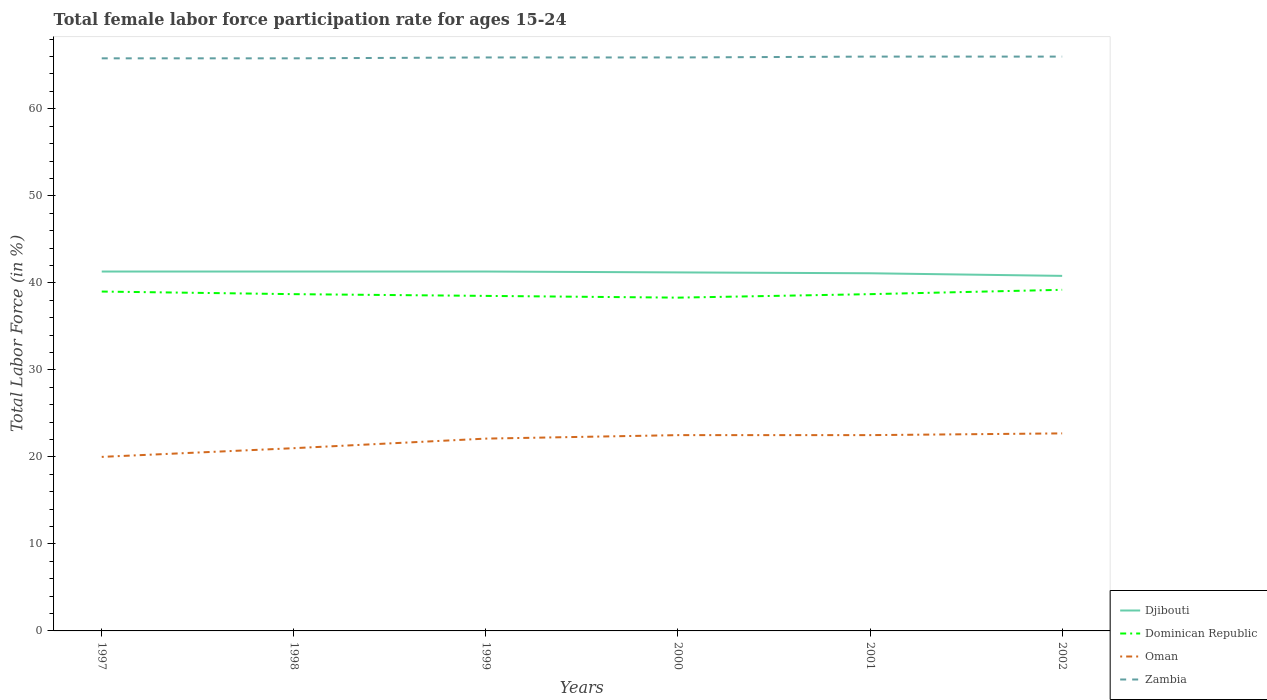How many different coloured lines are there?
Your answer should be very brief. 4. Across all years, what is the maximum female labor force participation rate in Zambia?
Your answer should be compact. 65.8. What is the total female labor force participation rate in Djibouti in the graph?
Offer a very short reply. 0.1. What is the difference between the highest and the second highest female labor force participation rate in Zambia?
Make the answer very short. 0.2. Is the female labor force participation rate in Djibouti strictly greater than the female labor force participation rate in Oman over the years?
Your response must be concise. No. How many lines are there?
Your answer should be compact. 4. Does the graph contain any zero values?
Provide a succinct answer. No. What is the title of the graph?
Offer a very short reply. Total female labor force participation rate for ages 15-24. Does "Macao" appear as one of the legend labels in the graph?
Offer a terse response. No. What is the Total Labor Force (in %) of Djibouti in 1997?
Your answer should be compact. 41.3. What is the Total Labor Force (in %) in Zambia in 1997?
Keep it short and to the point. 65.8. What is the Total Labor Force (in %) in Djibouti in 1998?
Your answer should be compact. 41.3. What is the Total Labor Force (in %) in Dominican Republic in 1998?
Your answer should be very brief. 38.7. What is the Total Labor Force (in %) of Oman in 1998?
Provide a short and direct response. 21. What is the Total Labor Force (in %) of Zambia in 1998?
Ensure brevity in your answer.  65.8. What is the Total Labor Force (in %) in Djibouti in 1999?
Make the answer very short. 41.3. What is the Total Labor Force (in %) of Dominican Republic in 1999?
Your answer should be compact. 38.5. What is the Total Labor Force (in %) in Oman in 1999?
Make the answer very short. 22.1. What is the Total Labor Force (in %) in Zambia in 1999?
Ensure brevity in your answer.  65.9. What is the Total Labor Force (in %) of Djibouti in 2000?
Offer a very short reply. 41.2. What is the Total Labor Force (in %) in Dominican Republic in 2000?
Offer a terse response. 38.3. What is the Total Labor Force (in %) in Oman in 2000?
Your answer should be very brief. 22.5. What is the Total Labor Force (in %) of Zambia in 2000?
Your response must be concise. 65.9. What is the Total Labor Force (in %) of Djibouti in 2001?
Your answer should be very brief. 41.1. What is the Total Labor Force (in %) of Dominican Republic in 2001?
Offer a very short reply. 38.7. What is the Total Labor Force (in %) of Zambia in 2001?
Provide a short and direct response. 66. What is the Total Labor Force (in %) of Djibouti in 2002?
Ensure brevity in your answer.  40.8. What is the Total Labor Force (in %) of Dominican Republic in 2002?
Keep it short and to the point. 39.2. What is the Total Labor Force (in %) in Oman in 2002?
Provide a short and direct response. 22.7. What is the Total Labor Force (in %) in Zambia in 2002?
Keep it short and to the point. 66. Across all years, what is the maximum Total Labor Force (in %) in Djibouti?
Keep it short and to the point. 41.3. Across all years, what is the maximum Total Labor Force (in %) in Dominican Republic?
Keep it short and to the point. 39.2. Across all years, what is the maximum Total Labor Force (in %) in Oman?
Your answer should be compact. 22.7. Across all years, what is the minimum Total Labor Force (in %) of Djibouti?
Provide a short and direct response. 40.8. Across all years, what is the minimum Total Labor Force (in %) in Dominican Republic?
Provide a succinct answer. 38.3. Across all years, what is the minimum Total Labor Force (in %) of Zambia?
Provide a succinct answer. 65.8. What is the total Total Labor Force (in %) in Djibouti in the graph?
Provide a succinct answer. 247. What is the total Total Labor Force (in %) of Dominican Republic in the graph?
Provide a succinct answer. 232.4. What is the total Total Labor Force (in %) in Oman in the graph?
Provide a short and direct response. 130.8. What is the total Total Labor Force (in %) of Zambia in the graph?
Offer a terse response. 395.4. What is the difference between the Total Labor Force (in %) in Dominican Republic in 1997 and that in 1998?
Your answer should be very brief. 0.3. What is the difference between the Total Labor Force (in %) in Zambia in 1997 and that in 1998?
Offer a terse response. 0. What is the difference between the Total Labor Force (in %) of Dominican Republic in 1997 and that in 1999?
Your response must be concise. 0.5. What is the difference between the Total Labor Force (in %) of Oman in 1997 and that in 1999?
Your response must be concise. -2.1. What is the difference between the Total Labor Force (in %) in Djibouti in 1997 and that in 2000?
Ensure brevity in your answer.  0.1. What is the difference between the Total Labor Force (in %) of Oman in 1997 and that in 2000?
Provide a short and direct response. -2.5. What is the difference between the Total Labor Force (in %) in Zambia in 1997 and that in 2000?
Make the answer very short. -0.1. What is the difference between the Total Labor Force (in %) of Djibouti in 1997 and that in 2001?
Offer a terse response. 0.2. What is the difference between the Total Labor Force (in %) of Dominican Republic in 1997 and that in 2001?
Your answer should be very brief. 0.3. What is the difference between the Total Labor Force (in %) in Oman in 1997 and that in 2001?
Your answer should be very brief. -2.5. What is the difference between the Total Labor Force (in %) of Zambia in 1997 and that in 2001?
Your answer should be compact. -0.2. What is the difference between the Total Labor Force (in %) in Dominican Republic in 1997 and that in 2002?
Keep it short and to the point. -0.2. What is the difference between the Total Labor Force (in %) in Zambia in 1997 and that in 2002?
Give a very brief answer. -0.2. What is the difference between the Total Labor Force (in %) in Djibouti in 1998 and that in 1999?
Offer a terse response. 0. What is the difference between the Total Labor Force (in %) in Dominican Republic in 1998 and that in 1999?
Offer a very short reply. 0.2. What is the difference between the Total Labor Force (in %) of Djibouti in 1998 and that in 2000?
Your answer should be very brief. 0.1. What is the difference between the Total Labor Force (in %) of Dominican Republic in 1998 and that in 2000?
Your answer should be compact. 0.4. What is the difference between the Total Labor Force (in %) of Oman in 1998 and that in 2000?
Offer a very short reply. -1.5. What is the difference between the Total Labor Force (in %) in Djibouti in 1998 and that in 2001?
Your answer should be compact. 0.2. What is the difference between the Total Labor Force (in %) of Dominican Republic in 1998 and that in 2001?
Keep it short and to the point. 0. What is the difference between the Total Labor Force (in %) in Oman in 1998 and that in 2001?
Provide a succinct answer. -1.5. What is the difference between the Total Labor Force (in %) in Oman in 1998 and that in 2002?
Ensure brevity in your answer.  -1.7. What is the difference between the Total Labor Force (in %) of Zambia in 1998 and that in 2002?
Give a very brief answer. -0.2. What is the difference between the Total Labor Force (in %) of Djibouti in 1999 and that in 2000?
Make the answer very short. 0.1. What is the difference between the Total Labor Force (in %) in Dominican Republic in 1999 and that in 2000?
Your answer should be very brief. 0.2. What is the difference between the Total Labor Force (in %) of Oman in 1999 and that in 2000?
Offer a very short reply. -0.4. What is the difference between the Total Labor Force (in %) of Dominican Republic in 1999 and that in 2001?
Offer a very short reply. -0.2. What is the difference between the Total Labor Force (in %) in Zambia in 1999 and that in 2001?
Your answer should be compact. -0.1. What is the difference between the Total Labor Force (in %) in Djibouti in 1999 and that in 2002?
Make the answer very short. 0.5. What is the difference between the Total Labor Force (in %) in Dominican Republic in 1999 and that in 2002?
Your answer should be very brief. -0.7. What is the difference between the Total Labor Force (in %) of Oman in 1999 and that in 2002?
Provide a short and direct response. -0.6. What is the difference between the Total Labor Force (in %) in Zambia in 1999 and that in 2002?
Make the answer very short. -0.1. What is the difference between the Total Labor Force (in %) in Djibouti in 2000 and that in 2001?
Offer a very short reply. 0.1. What is the difference between the Total Labor Force (in %) in Dominican Republic in 2000 and that in 2001?
Ensure brevity in your answer.  -0.4. What is the difference between the Total Labor Force (in %) in Oman in 2000 and that in 2001?
Your answer should be compact. 0. What is the difference between the Total Labor Force (in %) of Dominican Republic in 2000 and that in 2002?
Offer a very short reply. -0.9. What is the difference between the Total Labor Force (in %) in Oman in 2000 and that in 2002?
Keep it short and to the point. -0.2. What is the difference between the Total Labor Force (in %) of Djibouti in 2001 and that in 2002?
Offer a terse response. 0.3. What is the difference between the Total Labor Force (in %) of Djibouti in 1997 and the Total Labor Force (in %) of Dominican Republic in 1998?
Your answer should be compact. 2.6. What is the difference between the Total Labor Force (in %) of Djibouti in 1997 and the Total Labor Force (in %) of Oman in 1998?
Make the answer very short. 20.3. What is the difference between the Total Labor Force (in %) in Djibouti in 1997 and the Total Labor Force (in %) in Zambia in 1998?
Ensure brevity in your answer.  -24.5. What is the difference between the Total Labor Force (in %) of Dominican Republic in 1997 and the Total Labor Force (in %) of Oman in 1998?
Make the answer very short. 18. What is the difference between the Total Labor Force (in %) of Dominican Republic in 1997 and the Total Labor Force (in %) of Zambia in 1998?
Offer a terse response. -26.8. What is the difference between the Total Labor Force (in %) of Oman in 1997 and the Total Labor Force (in %) of Zambia in 1998?
Your answer should be compact. -45.8. What is the difference between the Total Labor Force (in %) of Djibouti in 1997 and the Total Labor Force (in %) of Dominican Republic in 1999?
Provide a short and direct response. 2.8. What is the difference between the Total Labor Force (in %) in Djibouti in 1997 and the Total Labor Force (in %) in Zambia in 1999?
Offer a very short reply. -24.6. What is the difference between the Total Labor Force (in %) of Dominican Republic in 1997 and the Total Labor Force (in %) of Zambia in 1999?
Keep it short and to the point. -26.9. What is the difference between the Total Labor Force (in %) of Oman in 1997 and the Total Labor Force (in %) of Zambia in 1999?
Offer a very short reply. -45.9. What is the difference between the Total Labor Force (in %) of Djibouti in 1997 and the Total Labor Force (in %) of Dominican Republic in 2000?
Your answer should be compact. 3. What is the difference between the Total Labor Force (in %) in Djibouti in 1997 and the Total Labor Force (in %) in Zambia in 2000?
Offer a very short reply. -24.6. What is the difference between the Total Labor Force (in %) in Dominican Republic in 1997 and the Total Labor Force (in %) in Oman in 2000?
Make the answer very short. 16.5. What is the difference between the Total Labor Force (in %) in Dominican Republic in 1997 and the Total Labor Force (in %) in Zambia in 2000?
Give a very brief answer. -26.9. What is the difference between the Total Labor Force (in %) in Oman in 1997 and the Total Labor Force (in %) in Zambia in 2000?
Keep it short and to the point. -45.9. What is the difference between the Total Labor Force (in %) in Djibouti in 1997 and the Total Labor Force (in %) in Oman in 2001?
Your answer should be very brief. 18.8. What is the difference between the Total Labor Force (in %) in Djibouti in 1997 and the Total Labor Force (in %) in Zambia in 2001?
Offer a terse response. -24.7. What is the difference between the Total Labor Force (in %) in Oman in 1997 and the Total Labor Force (in %) in Zambia in 2001?
Offer a very short reply. -46. What is the difference between the Total Labor Force (in %) of Djibouti in 1997 and the Total Labor Force (in %) of Zambia in 2002?
Provide a short and direct response. -24.7. What is the difference between the Total Labor Force (in %) of Oman in 1997 and the Total Labor Force (in %) of Zambia in 2002?
Give a very brief answer. -46. What is the difference between the Total Labor Force (in %) in Djibouti in 1998 and the Total Labor Force (in %) in Dominican Republic in 1999?
Ensure brevity in your answer.  2.8. What is the difference between the Total Labor Force (in %) in Djibouti in 1998 and the Total Labor Force (in %) in Oman in 1999?
Offer a very short reply. 19.2. What is the difference between the Total Labor Force (in %) of Djibouti in 1998 and the Total Labor Force (in %) of Zambia in 1999?
Give a very brief answer. -24.6. What is the difference between the Total Labor Force (in %) in Dominican Republic in 1998 and the Total Labor Force (in %) in Zambia in 1999?
Your response must be concise. -27.2. What is the difference between the Total Labor Force (in %) of Oman in 1998 and the Total Labor Force (in %) of Zambia in 1999?
Offer a very short reply. -44.9. What is the difference between the Total Labor Force (in %) of Djibouti in 1998 and the Total Labor Force (in %) of Zambia in 2000?
Make the answer very short. -24.6. What is the difference between the Total Labor Force (in %) of Dominican Republic in 1998 and the Total Labor Force (in %) of Oman in 2000?
Provide a succinct answer. 16.2. What is the difference between the Total Labor Force (in %) of Dominican Republic in 1998 and the Total Labor Force (in %) of Zambia in 2000?
Offer a terse response. -27.2. What is the difference between the Total Labor Force (in %) of Oman in 1998 and the Total Labor Force (in %) of Zambia in 2000?
Your answer should be very brief. -44.9. What is the difference between the Total Labor Force (in %) in Djibouti in 1998 and the Total Labor Force (in %) in Oman in 2001?
Ensure brevity in your answer.  18.8. What is the difference between the Total Labor Force (in %) of Djibouti in 1998 and the Total Labor Force (in %) of Zambia in 2001?
Your answer should be compact. -24.7. What is the difference between the Total Labor Force (in %) in Dominican Republic in 1998 and the Total Labor Force (in %) in Oman in 2001?
Ensure brevity in your answer.  16.2. What is the difference between the Total Labor Force (in %) of Dominican Republic in 1998 and the Total Labor Force (in %) of Zambia in 2001?
Provide a succinct answer. -27.3. What is the difference between the Total Labor Force (in %) of Oman in 1998 and the Total Labor Force (in %) of Zambia in 2001?
Your answer should be very brief. -45. What is the difference between the Total Labor Force (in %) in Djibouti in 1998 and the Total Labor Force (in %) in Oman in 2002?
Offer a terse response. 18.6. What is the difference between the Total Labor Force (in %) of Djibouti in 1998 and the Total Labor Force (in %) of Zambia in 2002?
Provide a succinct answer. -24.7. What is the difference between the Total Labor Force (in %) in Dominican Republic in 1998 and the Total Labor Force (in %) in Oman in 2002?
Offer a terse response. 16. What is the difference between the Total Labor Force (in %) in Dominican Republic in 1998 and the Total Labor Force (in %) in Zambia in 2002?
Your response must be concise. -27.3. What is the difference between the Total Labor Force (in %) in Oman in 1998 and the Total Labor Force (in %) in Zambia in 2002?
Ensure brevity in your answer.  -45. What is the difference between the Total Labor Force (in %) in Djibouti in 1999 and the Total Labor Force (in %) in Zambia in 2000?
Your answer should be compact. -24.6. What is the difference between the Total Labor Force (in %) of Dominican Republic in 1999 and the Total Labor Force (in %) of Zambia in 2000?
Your response must be concise. -27.4. What is the difference between the Total Labor Force (in %) of Oman in 1999 and the Total Labor Force (in %) of Zambia in 2000?
Give a very brief answer. -43.8. What is the difference between the Total Labor Force (in %) in Djibouti in 1999 and the Total Labor Force (in %) in Dominican Republic in 2001?
Provide a short and direct response. 2.6. What is the difference between the Total Labor Force (in %) of Djibouti in 1999 and the Total Labor Force (in %) of Oman in 2001?
Keep it short and to the point. 18.8. What is the difference between the Total Labor Force (in %) of Djibouti in 1999 and the Total Labor Force (in %) of Zambia in 2001?
Your response must be concise. -24.7. What is the difference between the Total Labor Force (in %) of Dominican Republic in 1999 and the Total Labor Force (in %) of Oman in 2001?
Offer a very short reply. 16. What is the difference between the Total Labor Force (in %) in Dominican Republic in 1999 and the Total Labor Force (in %) in Zambia in 2001?
Offer a very short reply. -27.5. What is the difference between the Total Labor Force (in %) in Oman in 1999 and the Total Labor Force (in %) in Zambia in 2001?
Ensure brevity in your answer.  -43.9. What is the difference between the Total Labor Force (in %) of Djibouti in 1999 and the Total Labor Force (in %) of Zambia in 2002?
Your response must be concise. -24.7. What is the difference between the Total Labor Force (in %) in Dominican Republic in 1999 and the Total Labor Force (in %) in Oman in 2002?
Provide a short and direct response. 15.8. What is the difference between the Total Labor Force (in %) of Dominican Republic in 1999 and the Total Labor Force (in %) of Zambia in 2002?
Ensure brevity in your answer.  -27.5. What is the difference between the Total Labor Force (in %) of Oman in 1999 and the Total Labor Force (in %) of Zambia in 2002?
Your answer should be compact. -43.9. What is the difference between the Total Labor Force (in %) in Djibouti in 2000 and the Total Labor Force (in %) in Zambia in 2001?
Give a very brief answer. -24.8. What is the difference between the Total Labor Force (in %) of Dominican Republic in 2000 and the Total Labor Force (in %) of Oman in 2001?
Keep it short and to the point. 15.8. What is the difference between the Total Labor Force (in %) of Dominican Republic in 2000 and the Total Labor Force (in %) of Zambia in 2001?
Offer a terse response. -27.7. What is the difference between the Total Labor Force (in %) of Oman in 2000 and the Total Labor Force (in %) of Zambia in 2001?
Your answer should be compact. -43.5. What is the difference between the Total Labor Force (in %) in Djibouti in 2000 and the Total Labor Force (in %) in Dominican Republic in 2002?
Your answer should be compact. 2. What is the difference between the Total Labor Force (in %) of Djibouti in 2000 and the Total Labor Force (in %) of Oman in 2002?
Your answer should be compact. 18.5. What is the difference between the Total Labor Force (in %) of Djibouti in 2000 and the Total Labor Force (in %) of Zambia in 2002?
Provide a succinct answer. -24.8. What is the difference between the Total Labor Force (in %) of Dominican Republic in 2000 and the Total Labor Force (in %) of Oman in 2002?
Keep it short and to the point. 15.6. What is the difference between the Total Labor Force (in %) in Dominican Republic in 2000 and the Total Labor Force (in %) in Zambia in 2002?
Your answer should be compact. -27.7. What is the difference between the Total Labor Force (in %) in Oman in 2000 and the Total Labor Force (in %) in Zambia in 2002?
Provide a succinct answer. -43.5. What is the difference between the Total Labor Force (in %) in Djibouti in 2001 and the Total Labor Force (in %) in Oman in 2002?
Make the answer very short. 18.4. What is the difference between the Total Labor Force (in %) in Djibouti in 2001 and the Total Labor Force (in %) in Zambia in 2002?
Make the answer very short. -24.9. What is the difference between the Total Labor Force (in %) of Dominican Republic in 2001 and the Total Labor Force (in %) of Zambia in 2002?
Keep it short and to the point. -27.3. What is the difference between the Total Labor Force (in %) in Oman in 2001 and the Total Labor Force (in %) in Zambia in 2002?
Keep it short and to the point. -43.5. What is the average Total Labor Force (in %) of Djibouti per year?
Offer a very short reply. 41.17. What is the average Total Labor Force (in %) of Dominican Republic per year?
Give a very brief answer. 38.73. What is the average Total Labor Force (in %) in Oman per year?
Your answer should be very brief. 21.8. What is the average Total Labor Force (in %) in Zambia per year?
Give a very brief answer. 65.9. In the year 1997, what is the difference between the Total Labor Force (in %) of Djibouti and Total Labor Force (in %) of Oman?
Provide a succinct answer. 21.3. In the year 1997, what is the difference between the Total Labor Force (in %) in Djibouti and Total Labor Force (in %) in Zambia?
Your response must be concise. -24.5. In the year 1997, what is the difference between the Total Labor Force (in %) in Dominican Republic and Total Labor Force (in %) in Oman?
Your response must be concise. 19. In the year 1997, what is the difference between the Total Labor Force (in %) in Dominican Republic and Total Labor Force (in %) in Zambia?
Provide a succinct answer. -26.8. In the year 1997, what is the difference between the Total Labor Force (in %) of Oman and Total Labor Force (in %) of Zambia?
Make the answer very short. -45.8. In the year 1998, what is the difference between the Total Labor Force (in %) in Djibouti and Total Labor Force (in %) in Dominican Republic?
Offer a terse response. 2.6. In the year 1998, what is the difference between the Total Labor Force (in %) of Djibouti and Total Labor Force (in %) of Oman?
Provide a succinct answer. 20.3. In the year 1998, what is the difference between the Total Labor Force (in %) of Djibouti and Total Labor Force (in %) of Zambia?
Give a very brief answer. -24.5. In the year 1998, what is the difference between the Total Labor Force (in %) of Dominican Republic and Total Labor Force (in %) of Zambia?
Make the answer very short. -27.1. In the year 1998, what is the difference between the Total Labor Force (in %) of Oman and Total Labor Force (in %) of Zambia?
Give a very brief answer. -44.8. In the year 1999, what is the difference between the Total Labor Force (in %) of Djibouti and Total Labor Force (in %) of Dominican Republic?
Provide a succinct answer. 2.8. In the year 1999, what is the difference between the Total Labor Force (in %) in Djibouti and Total Labor Force (in %) in Oman?
Your answer should be compact. 19.2. In the year 1999, what is the difference between the Total Labor Force (in %) in Djibouti and Total Labor Force (in %) in Zambia?
Your response must be concise. -24.6. In the year 1999, what is the difference between the Total Labor Force (in %) of Dominican Republic and Total Labor Force (in %) of Oman?
Your answer should be compact. 16.4. In the year 1999, what is the difference between the Total Labor Force (in %) in Dominican Republic and Total Labor Force (in %) in Zambia?
Keep it short and to the point. -27.4. In the year 1999, what is the difference between the Total Labor Force (in %) in Oman and Total Labor Force (in %) in Zambia?
Keep it short and to the point. -43.8. In the year 2000, what is the difference between the Total Labor Force (in %) in Djibouti and Total Labor Force (in %) in Dominican Republic?
Offer a very short reply. 2.9. In the year 2000, what is the difference between the Total Labor Force (in %) in Djibouti and Total Labor Force (in %) in Zambia?
Provide a succinct answer. -24.7. In the year 2000, what is the difference between the Total Labor Force (in %) of Dominican Republic and Total Labor Force (in %) of Oman?
Ensure brevity in your answer.  15.8. In the year 2000, what is the difference between the Total Labor Force (in %) in Dominican Republic and Total Labor Force (in %) in Zambia?
Keep it short and to the point. -27.6. In the year 2000, what is the difference between the Total Labor Force (in %) of Oman and Total Labor Force (in %) of Zambia?
Offer a very short reply. -43.4. In the year 2001, what is the difference between the Total Labor Force (in %) of Djibouti and Total Labor Force (in %) of Zambia?
Ensure brevity in your answer.  -24.9. In the year 2001, what is the difference between the Total Labor Force (in %) of Dominican Republic and Total Labor Force (in %) of Zambia?
Make the answer very short. -27.3. In the year 2001, what is the difference between the Total Labor Force (in %) in Oman and Total Labor Force (in %) in Zambia?
Your answer should be compact. -43.5. In the year 2002, what is the difference between the Total Labor Force (in %) of Djibouti and Total Labor Force (in %) of Dominican Republic?
Your answer should be compact. 1.6. In the year 2002, what is the difference between the Total Labor Force (in %) in Djibouti and Total Labor Force (in %) in Oman?
Offer a terse response. 18.1. In the year 2002, what is the difference between the Total Labor Force (in %) of Djibouti and Total Labor Force (in %) of Zambia?
Keep it short and to the point. -25.2. In the year 2002, what is the difference between the Total Labor Force (in %) in Dominican Republic and Total Labor Force (in %) in Oman?
Give a very brief answer. 16.5. In the year 2002, what is the difference between the Total Labor Force (in %) in Dominican Republic and Total Labor Force (in %) in Zambia?
Give a very brief answer. -26.8. In the year 2002, what is the difference between the Total Labor Force (in %) in Oman and Total Labor Force (in %) in Zambia?
Your answer should be very brief. -43.3. What is the ratio of the Total Labor Force (in %) of Dominican Republic in 1997 to that in 1998?
Give a very brief answer. 1.01. What is the ratio of the Total Labor Force (in %) in Oman in 1997 to that in 1998?
Your answer should be very brief. 0.95. What is the ratio of the Total Labor Force (in %) of Zambia in 1997 to that in 1998?
Offer a very short reply. 1. What is the ratio of the Total Labor Force (in %) in Djibouti in 1997 to that in 1999?
Offer a terse response. 1. What is the ratio of the Total Labor Force (in %) in Oman in 1997 to that in 1999?
Provide a short and direct response. 0.91. What is the ratio of the Total Labor Force (in %) in Dominican Republic in 1997 to that in 2000?
Your response must be concise. 1.02. What is the ratio of the Total Labor Force (in %) in Oman in 1997 to that in 2000?
Offer a terse response. 0.89. What is the ratio of the Total Labor Force (in %) of Djibouti in 1997 to that in 2001?
Your response must be concise. 1. What is the ratio of the Total Labor Force (in %) in Zambia in 1997 to that in 2001?
Offer a terse response. 1. What is the ratio of the Total Labor Force (in %) of Djibouti in 1997 to that in 2002?
Provide a succinct answer. 1.01. What is the ratio of the Total Labor Force (in %) in Oman in 1997 to that in 2002?
Ensure brevity in your answer.  0.88. What is the ratio of the Total Labor Force (in %) of Djibouti in 1998 to that in 1999?
Your response must be concise. 1. What is the ratio of the Total Labor Force (in %) in Oman in 1998 to that in 1999?
Provide a succinct answer. 0.95. What is the ratio of the Total Labor Force (in %) of Zambia in 1998 to that in 1999?
Your answer should be compact. 1. What is the ratio of the Total Labor Force (in %) of Dominican Republic in 1998 to that in 2000?
Make the answer very short. 1.01. What is the ratio of the Total Labor Force (in %) in Oman in 1998 to that in 2000?
Give a very brief answer. 0.93. What is the ratio of the Total Labor Force (in %) of Zambia in 1998 to that in 2000?
Your answer should be very brief. 1. What is the ratio of the Total Labor Force (in %) of Djibouti in 1998 to that in 2001?
Provide a succinct answer. 1. What is the ratio of the Total Labor Force (in %) of Dominican Republic in 1998 to that in 2001?
Give a very brief answer. 1. What is the ratio of the Total Labor Force (in %) of Djibouti in 1998 to that in 2002?
Make the answer very short. 1.01. What is the ratio of the Total Labor Force (in %) in Dominican Republic in 1998 to that in 2002?
Give a very brief answer. 0.99. What is the ratio of the Total Labor Force (in %) of Oman in 1998 to that in 2002?
Offer a very short reply. 0.93. What is the ratio of the Total Labor Force (in %) in Oman in 1999 to that in 2000?
Provide a succinct answer. 0.98. What is the ratio of the Total Labor Force (in %) in Djibouti in 1999 to that in 2001?
Offer a very short reply. 1. What is the ratio of the Total Labor Force (in %) in Dominican Republic in 1999 to that in 2001?
Ensure brevity in your answer.  0.99. What is the ratio of the Total Labor Force (in %) in Oman in 1999 to that in 2001?
Keep it short and to the point. 0.98. What is the ratio of the Total Labor Force (in %) of Zambia in 1999 to that in 2001?
Provide a short and direct response. 1. What is the ratio of the Total Labor Force (in %) in Djibouti in 1999 to that in 2002?
Your answer should be very brief. 1.01. What is the ratio of the Total Labor Force (in %) of Dominican Republic in 1999 to that in 2002?
Ensure brevity in your answer.  0.98. What is the ratio of the Total Labor Force (in %) of Oman in 1999 to that in 2002?
Ensure brevity in your answer.  0.97. What is the ratio of the Total Labor Force (in %) of Djibouti in 2000 to that in 2001?
Provide a succinct answer. 1. What is the ratio of the Total Labor Force (in %) in Djibouti in 2000 to that in 2002?
Your response must be concise. 1.01. What is the ratio of the Total Labor Force (in %) in Dominican Republic in 2000 to that in 2002?
Provide a succinct answer. 0.98. What is the ratio of the Total Labor Force (in %) of Oman in 2000 to that in 2002?
Provide a short and direct response. 0.99. What is the ratio of the Total Labor Force (in %) of Djibouti in 2001 to that in 2002?
Your answer should be very brief. 1.01. What is the ratio of the Total Labor Force (in %) of Dominican Republic in 2001 to that in 2002?
Keep it short and to the point. 0.99. What is the ratio of the Total Labor Force (in %) in Oman in 2001 to that in 2002?
Ensure brevity in your answer.  0.99. What is the difference between the highest and the second highest Total Labor Force (in %) of Djibouti?
Ensure brevity in your answer.  0. What is the difference between the highest and the second highest Total Labor Force (in %) in Oman?
Give a very brief answer. 0.2. What is the difference between the highest and the lowest Total Labor Force (in %) of Djibouti?
Give a very brief answer. 0.5. What is the difference between the highest and the lowest Total Labor Force (in %) in Dominican Republic?
Your response must be concise. 0.9. What is the difference between the highest and the lowest Total Labor Force (in %) of Oman?
Offer a terse response. 2.7. What is the difference between the highest and the lowest Total Labor Force (in %) of Zambia?
Provide a short and direct response. 0.2. 